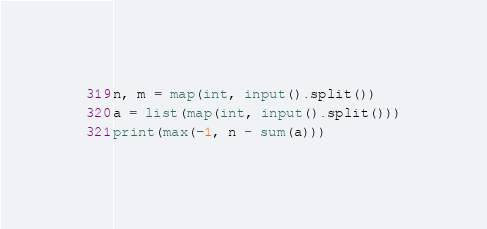<code> <loc_0><loc_0><loc_500><loc_500><_Python_>n, m = map(int, input().split())
a = list(map(int, input().split()))
print(max(-1, n - sum(a)))</code> 